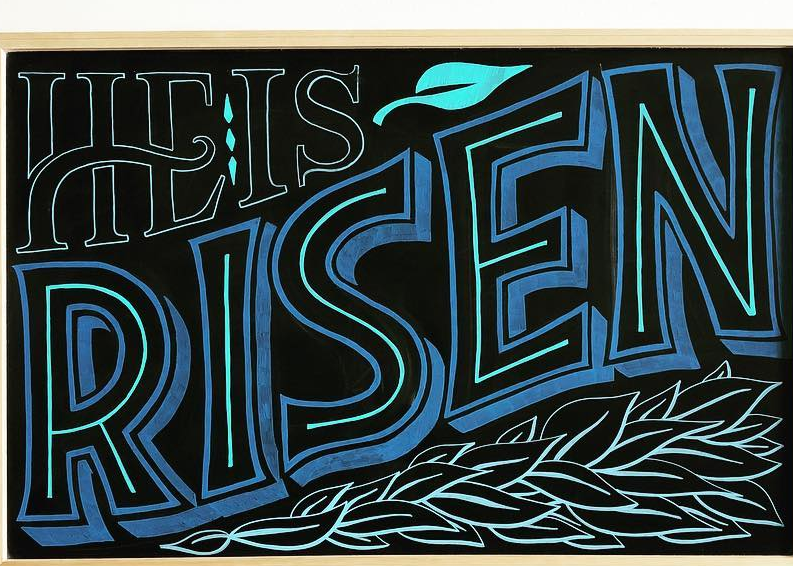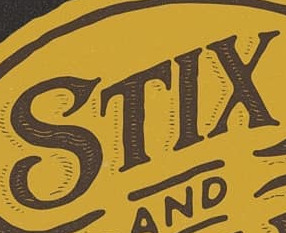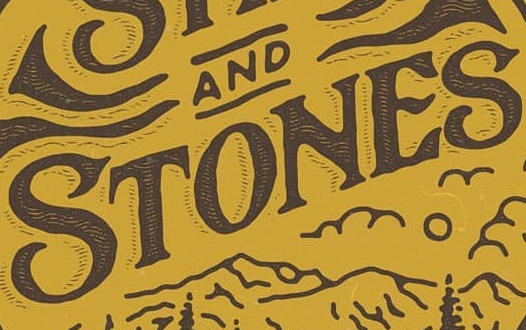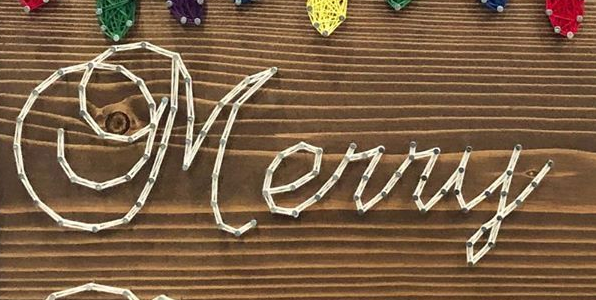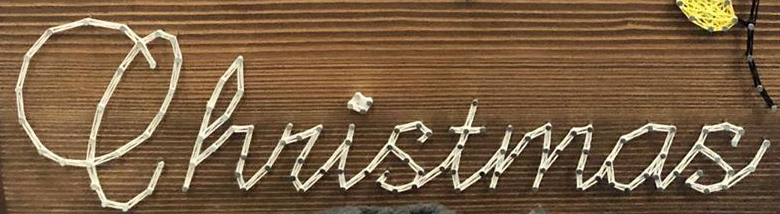Transcribe the words shown in these images in order, separated by a semicolon. RISEN; STIX; STONES; Merry; Christmas 